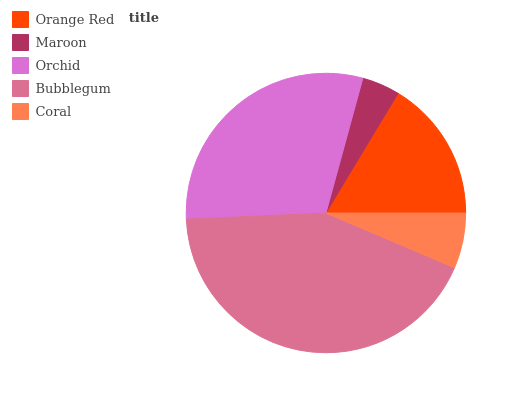Is Maroon the minimum?
Answer yes or no. Yes. Is Bubblegum the maximum?
Answer yes or no. Yes. Is Orchid the minimum?
Answer yes or no. No. Is Orchid the maximum?
Answer yes or no. No. Is Orchid greater than Maroon?
Answer yes or no. Yes. Is Maroon less than Orchid?
Answer yes or no. Yes. Is Maroon greater than Orchid?
Answer yes or no. No. Is Orchid less than Maroon?
Answer yes or no. No. Is Orange Red the high median?
Answer yes or no. Yes. Is Orange Red the low median?
Answer yes or no. Yes. Is Bubblegum the high median?
Answer yes or no. No. Is Coral the low median?
Answer yes or no. No. 